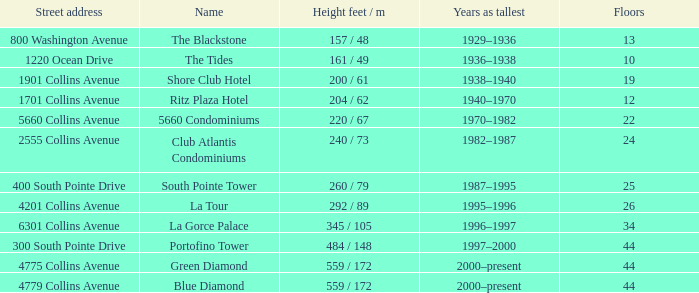What is the height of the Tides with less than 34 floors? 161 / 49. 